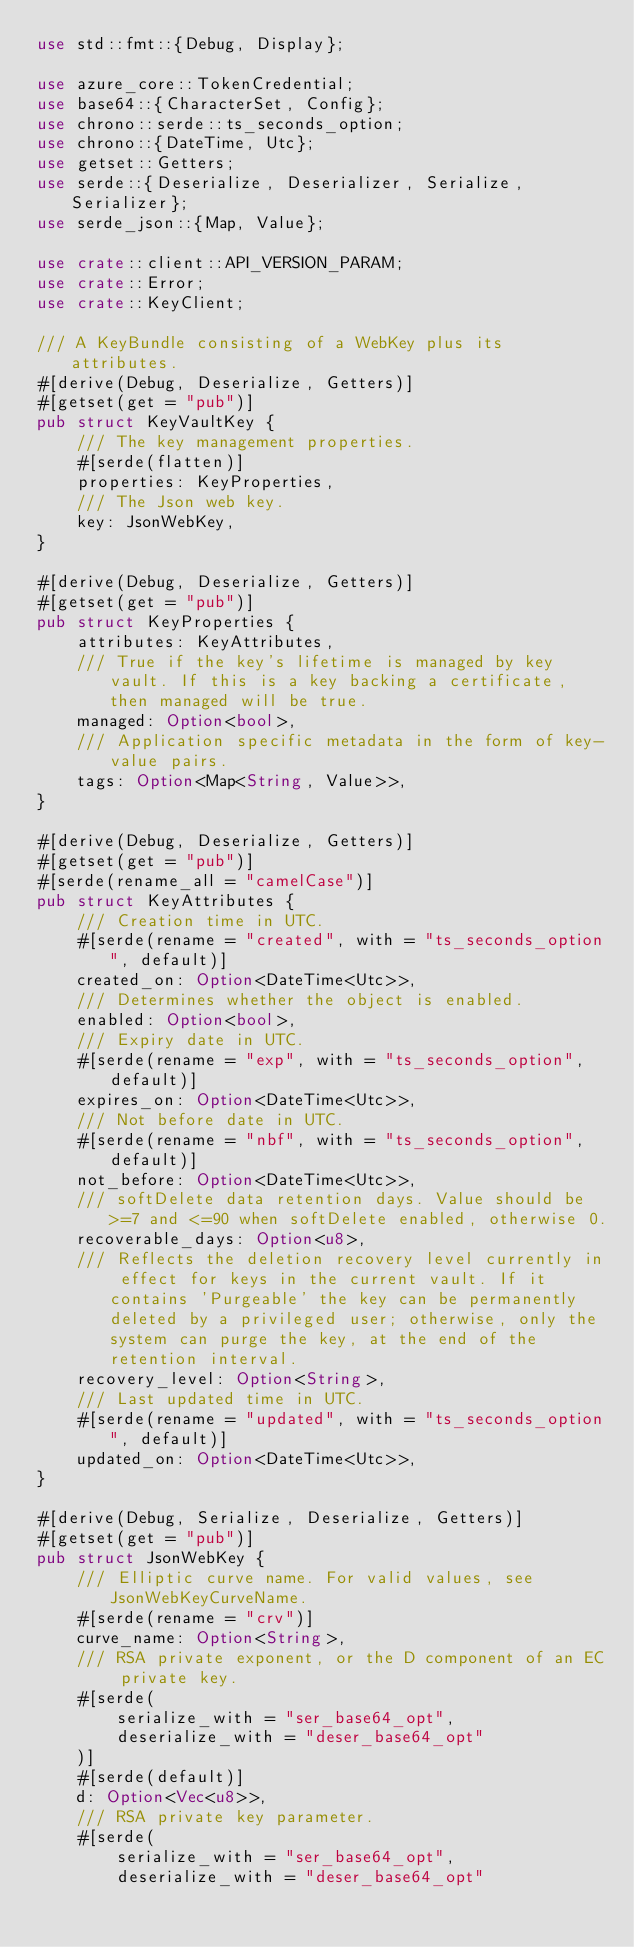Convert code to text. <code><loc_0><loc_0><loc_500><loc_500><_Rust_>use std::fmt::{Debug, Display};

use azure_core::TokenCredential;
use base64::{CharacterSet, Config};
use chrono::serde::ts_seconds_option;
use chrono::{DateTime, Utc};
use getset::Getters;
use serde::{Deserialize, Deserializer, Serialize, Serializer};
use serde_json::{Map, Value};

use crate::client::API_VERSION_PARAM;
use crate::Error;
use crate::KeyClient;

/// A KeyBundle consisting of a WebKey plus its attributes.
#[derive(Debug, Deserialize, Getters)]
#[getset(get = "pub")]
pub struct KeyVaultKey {
    /// The key management properties.
    #[serde(flatten)]
    properties: KeyProperties,
    /// The Json web key.
    key: JsonWebKey,
}

#[derive(Debug, Deserialize, Getters)]
#[getset(get = "pub")]
pub struct KeyProperties {
    attributes: KeyAttributes,
    /// True if the key's lifetime is managed by key vault. If this is a key backing a certificate, then managed will be true.
    managed: Option<bool>,
    /// Application specific metadata in the form of key-value pairs.
    tags: Option<Map<String, Value>>,
}

#[derive(Debug, Deserialize, Getters)]
#[getset(get = "pub")]
#[serde(rename_all = "camelCase")]
pub struct KeyAttributes {
    /// Creation time in UTC.
    #[serde(rename = "created", with = "ts_seconds_option", default)]
    created_on: Option<DateTime<Utc>>,
    /// Determines whether the object is enabled.
    enabled: Option<bool>,
    /// Expiry date in UTC.
    #[serde(rename = "exp", with = "ts_seconds_option", default)]
    expires_on: Option<DateTime<Utc>>,
    /// Not before date in UTC.
    #[serde(rename = "nbf", with = "ts_seconds_option", default)]
    not_before: Option<DateTime<Utc>>,
    /// softDelete data retention days. Value should be >=7 and <=90 when softDelete enabled, otherwise 0.
    recoverable_days: Option<u8>,
    /// Reflects the deletion recovery level currently in effect for keys in the current vault. If it contains 'Purgeable' the key can be permanently deleted by a privileged user; otherwise, only the system can purge the key, at the end of the retention interval.
    recovery_level: Option<String>,
    /// Last updated time in UTC.
    #[serde(rename = "updated", with = "ts_seconds_option", default)]
    updated_on: Option<DateTime<Utc>>,
}

#[derive(Debug, Serialize, Deserialize, Getters)]
#[getset(get = "pub")]
pub struct JsonWebKey {
    /// Elliptic curve name. For valid values, see JsonWebKeyCurveName.
    #[serde(rename = "crv")]
    curve_name: Option<String>,
    /// RSA private exponent, or the D component of an EC private key.
    #[serde(
        serialize_with = "ser_base64_opt",
        deserialize_with = "deser_base64_opt"
    )]
    #[serde(default)]
    d: Option<Vec<u8>>,
    /// RSA private key parameter.
    #[serde(
        serialize_with = "ser_base64_opt",
        deserialize_with = "deser_base64_opt"</code> 